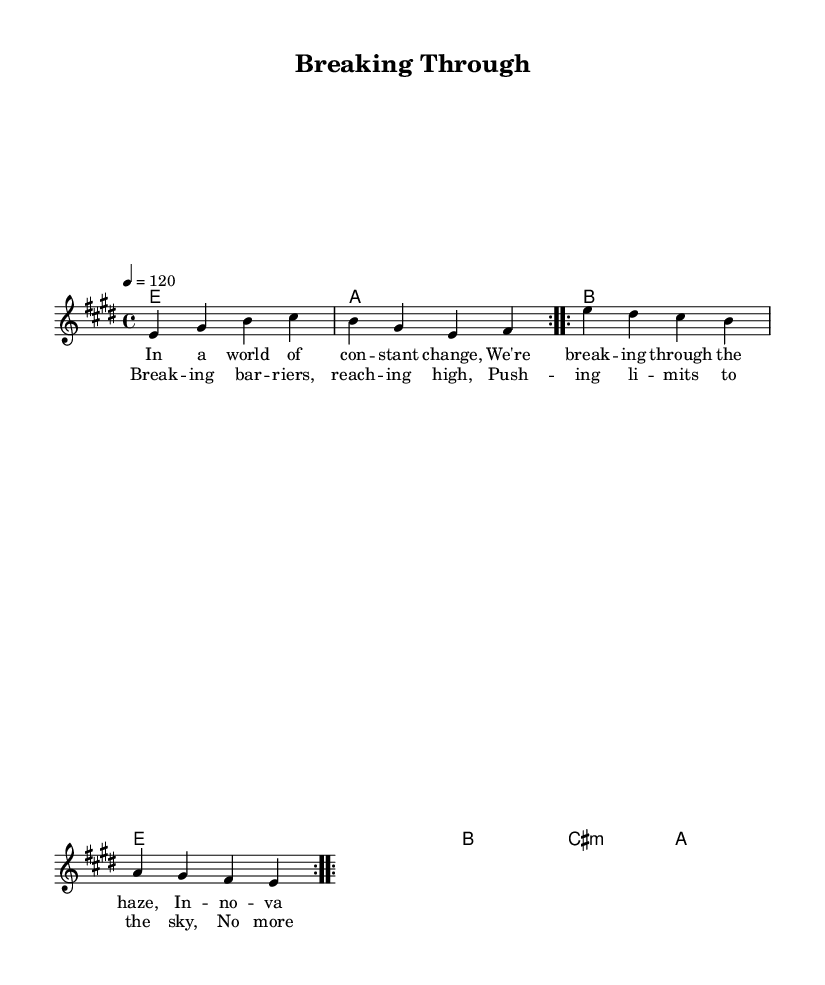What is the key signature of this music? The key signature is E major, which has four sharps: F#, C#, G#, and D#.
Answer: E major What is the time signature? The time signature is specified as 4/4, indicating four beats per measure with the quarter note receiving one beat.
Answer: 4/4 What tempo marking is indicated in the score? The tempo marking is shown as 4 = 120, meaning there are 120 beats per minute.
Answer: 120 How many measures are in the melody section? There are a total of four measures in the melody section, as indicated by the repetition markings.
Answer: 4 What is the first lyric in the verse section? The first lyric of the verse is "In a world of constant change".
Answer: In a world of constant change What is the primary theme expressed in the chorus? The primary theme expressed in the chorus revolves around "breaking barriers" and "reaching high," emphasizing overcoming limits.
Answer: Breaking barriers How many times is the chord progression repeated? The chord progression is repeated twice for both sections of the music, as indicated by the repeat markings.
Answer: 2 